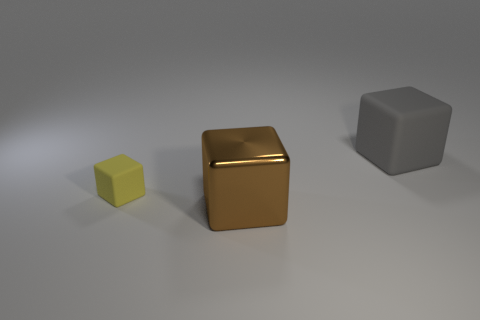Subtract all cyan blocks. Subtract all gray spheres. How many blocks are left? 3 Add 1 tiny gray rubber cylinders. How many objects exist? 4 Add 3 gray matte objects. How many gray matte objects exist? 4 Subtract 0 green spheres. How many objects are left? 3 Subtract all big green rubber objects. Subtract all big gray matte things. How many objects are left? 2 Add 2 big rubber cubes. How many big rubber cubes are left? 3 